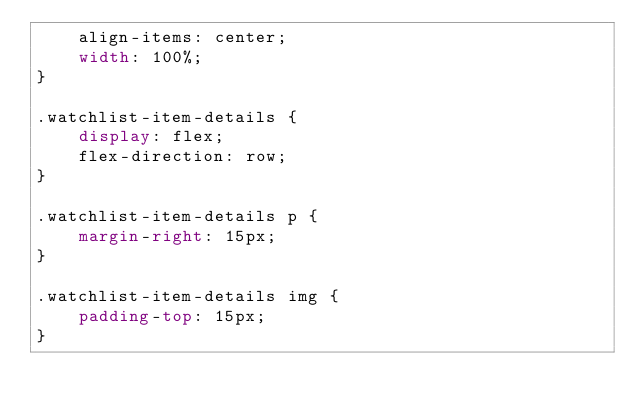Convert code to text. <code><loc_0><loc_0><loc_500><loc_500><_CSS_>    align-items: center;
    width: 100%;
}

.watchlist-item-details {
    display: flex;
    flex-direction: row;
}

.watchlist-item-details p {
    margin-right: 15px;
}

.watchlist-item-details img {
    padding-top: 15px;
}
</code> 